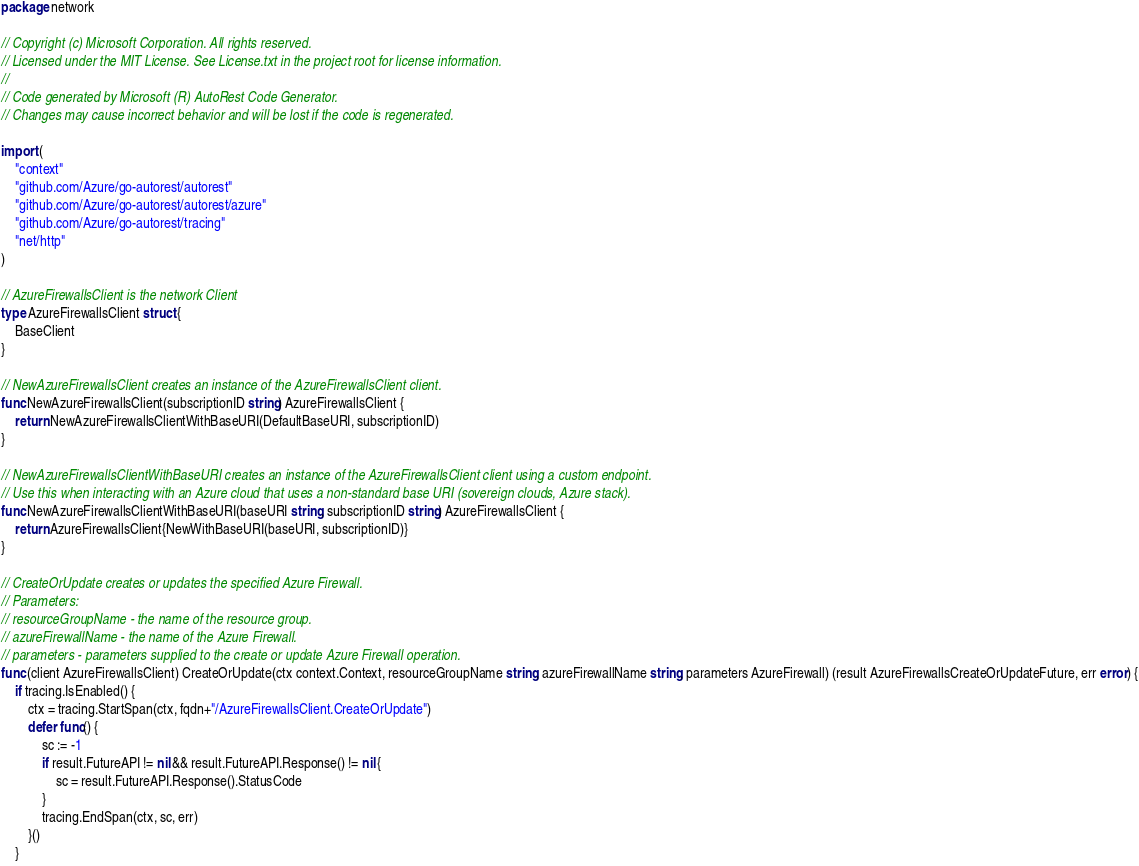Convert code to text. <code><loc_0><loc_0><loc_500><loc_500><_Go_>package network

// Copyright (c) Microsoft Corporation. All rights reserved.
// Licensed under the MIT License. See License.txt in the project root for license information.
//
// Code generated by Microsoft (R) AutoRest Code Generator.
// Changes may cause incorrect behavior and will be lost if the code is regenerated.

import (
	"context"
	"github.com/Azure/go-autorest/autorest"
	"github.com/Azure/go-autorest/autorest/azure"
	"github.com/Azure/go-autorest/tracing"
	"net/http"
)

// AzureFirewallsClient is the network Client
type AzureFirewallsClient struct {
	BaseClient
}

// NewAzureFirewallsClient creates an instance of the AzureFirewallsClient client.
func NewAzureFirewallsClient(subscriptionID string) AzureFirewallsClient {
	return NewAzureFirewallsClientWithBaseURI(DefaultBaseURI, subscriptionID)
}

// NewAzureFirewallsClientWithBaseURI creates an instance of the AzureFirewallsClient client using a custom endpoint.
// Use this when interacting with an Azure cloud that uses a non-standard base URI (sovereign clouds, Azure stack).
func NewAzureFirewallsClientWithBaseURI(baseURI string, subscriptionID string) AzureFirewallsClient {
	return AzureFirewallsClient{NewWithBaseURI(baseURI, subscriptionID)}
}

// CreateOrUpdate creates or updates the specified Azure Firewall.
// Parameters:
// resourceGroupName - the name of the resource group.
// azureFirewallName - the name of the Azure Firewall.
// parameters - parameters supplied to the create or update Azure Firewall operation.
func (client AzureFirewallsClient) CreateOrUpdate(ctx context.Context, resourceGroupName string, azureFirewallName string, parameters AzureFirewall) (result AzureFirewallsCreateOrUpdateFuture, err error) {
	if tracing.IsEnabled() {
		ctx = tracing.StartSpan(ctx, fqdn+"/AzureFirewallsClient.CreateOrUpdate")
		defer func() {
			sc := -1
			if result.FutureAPI != nil && result.FutureAPI.Response() != nil {
				sc = result.FutureAPI.Response().StatusCode
			}
			tracing.EndSpan(ctx, sc, err)
		}()
	}</code> 